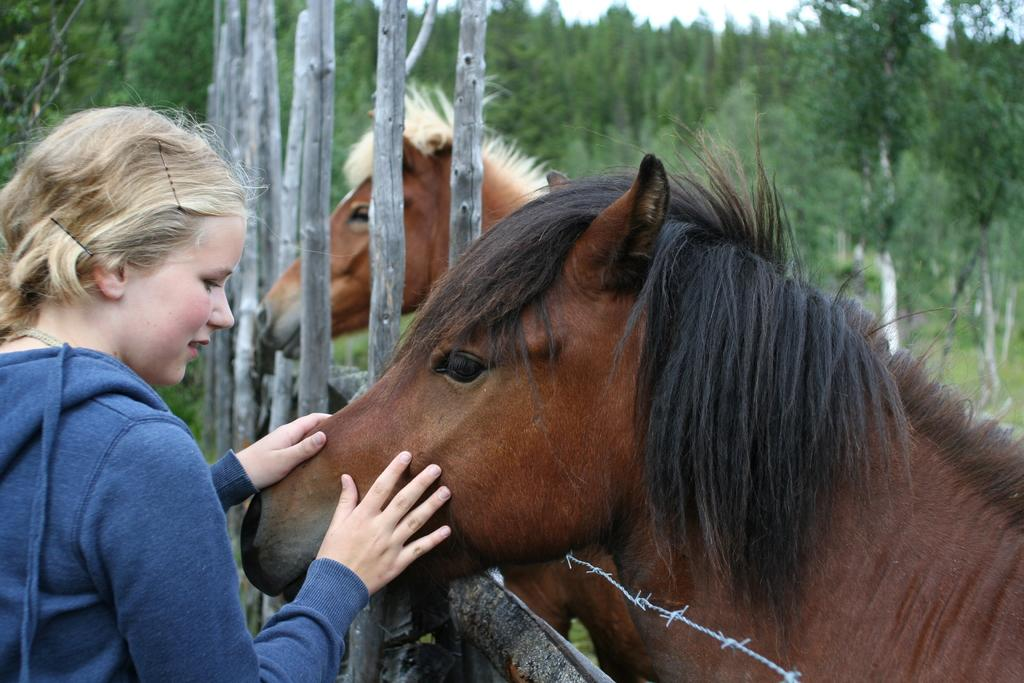Who is the main subject in the image? There is a lady in the image. What is the lady holding in the image? The lady is holding a horse. Are there any other horses in the image? Yes, there is another horse beside the first horse. What can be seen in the background of the image? There are plants around the horses. What type of music is playing in the background of the image? There is no music present in the image. Can you see a suit hanging on the horse in the image? There is no suit visible on the horses in the image. 